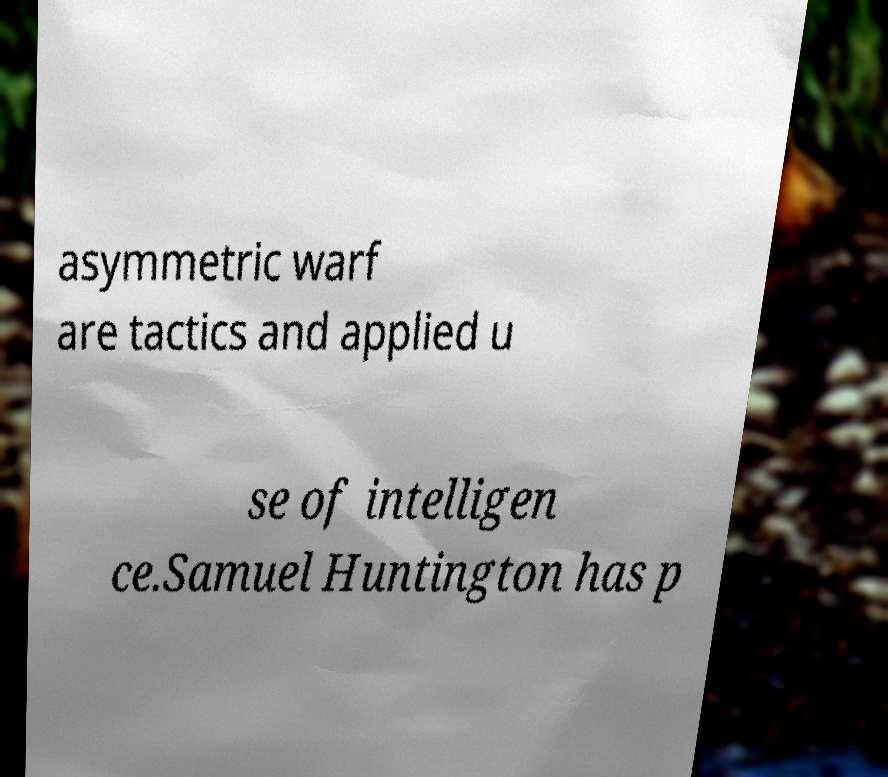What messages or text are displayed in this image? I need them in a readable, typed format. asymmetric warf are tactics and applied u se of intelligen ce.Samuel Huntington has p 